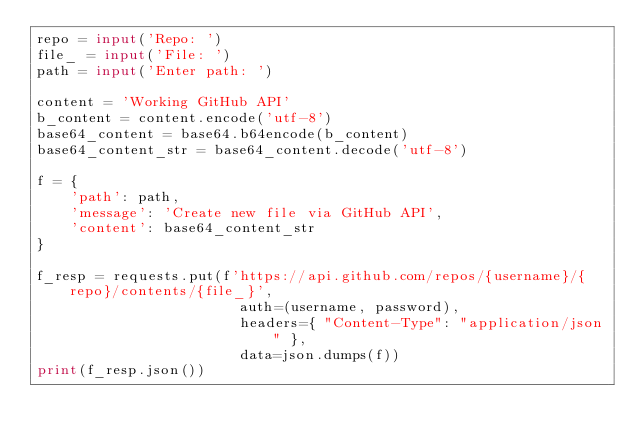<code> <loc_0><loc_0><loc_500><loc_500><_Python_>repo = input('Repo: ')
file_ = input('File: ')
path = input('Enter path: ')

content = 'Working GitHub API'
b_content = content.encode('utf-8')
base64_content = base64.b64encode(b_content)
base64_content_str = base64_content.decode('utf-8')

f = {
    'path': path,
    'message': 'Create new file via GitHub API',
    'content': base64_content_str
}

f_resp = requests.put(f'https://api.github.com/repos/{username}/{repo}/contents/{file_}', 
                        auth=(username, password), 
                        headers={ "Content-Type": "application/json" }, 
                        data=json.dumps(f))
print(f_resp.json())</code> 